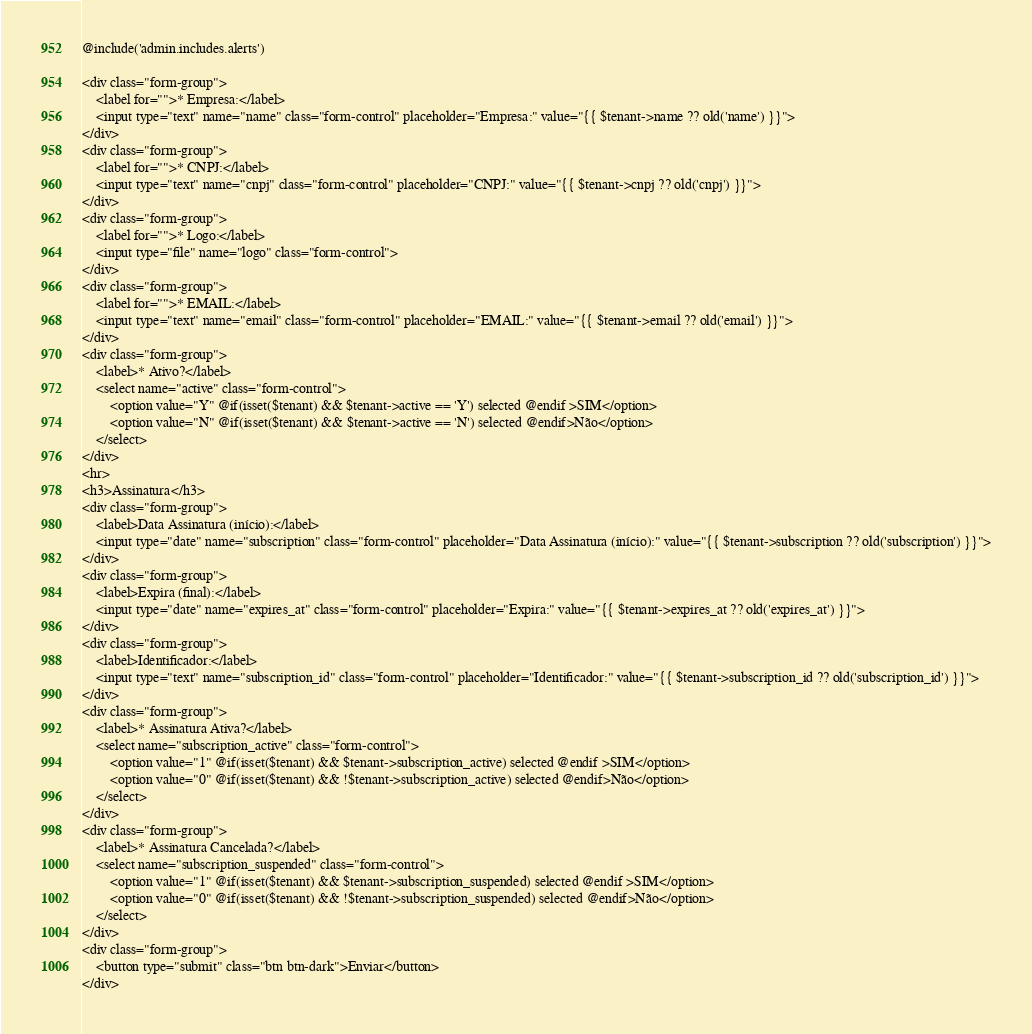Convert code to text. <code><loc_0><loc_0><loc_500><loc_500><_PHP_>@include('admin.includes.alerts')

<div class="form-group">
    <label for="">* Empresa:</label>
    <input type="text" name="name" class="form-control" placeholder="Empresa:" value="{{ $tenant->name ?? old('name') }}">
</div>
<div class="form-group">
    <label for="">* CNPJ:</label>
    <input type="text" name="cnpj" class="form-control" placeholder="CNPJ:" value="{{ $tenant->cnpj ?? old('cnpj') }}">
</div>
<div class="form-group">
    <label for="">* Logo:</label>
    <input type="file" name="logo" class="form-control">
</div>
<div class="form-group">
    <label for="">* EMAIL:</label>
    <input type="text" name="email" class="form-control" placeholder="EMAIL:" value="{{ $tenant->email ?? old('email') }}">
</div>
<div class="form-group">
    <label>* Ativo?</label>
    <select name="active" class="form-control">
        <option value="Y" @if(isset($tenant) && $tenant->active == 'Y') selected @endif >SIM</option>
        <option value="N" @if(isset($tenant) && $tenant->active == 'N') selected @endif>Não</option>
    </select>
</div>
<hr>
<h3>Assinatura</h3>
<div class="form-group">
    <label>Data Assinatura (início):</label>
    <input type="date" name="subscription" class="form-control" placeholder="Data Assinatura (início):" value="{{ $tenant->subscription ?? old('subscription') }}">
</div>
<div class="form-group">
    <label>Expira (final):</label>
    <input type="date" name="expires_at" class="form-control" placeholder="Expira:" value="{{ $tenant->expires_at ?? old('expires_at') }}">
</div>
<div class="form-group">
    <label>Identificador:</label>
    <input type="text" name="subscription_id" class="form-control" placeholder="Identificador:" value="{{ $tenant->subscription_id ?? old('subscription_id') }}">
</div>
<div class="form-group">
    <label>* Assinatura Ativa?</label>
    <select name="subscription_active" class="form-control">
        <option value="1" @if(isset($tenant) && $tenant->subscription_active) selected @endif >SIM</option>
        <option value="0" @if(isset($tenant) && !$tenant->subscription_active) selected @endif>Não</option>
    </select>
</div>
<div class="form-group">
    <label>* Assinatura Cancelada?</label>
    <select name="subscription_suspended" class="form-control">
        <option value="1" @if(isset($tenant) && $tenant->subscription_suspended) selected @endif >SIM</option>
        <option value="0" @if(isset($tenant) && !$tenant->subscription_suspended) selected @endif>Não</option>
    </select>
</div>
<div class="form-group">
    <button type="submit" class="btn btn-dark">Enviar</button>
</div></code> 